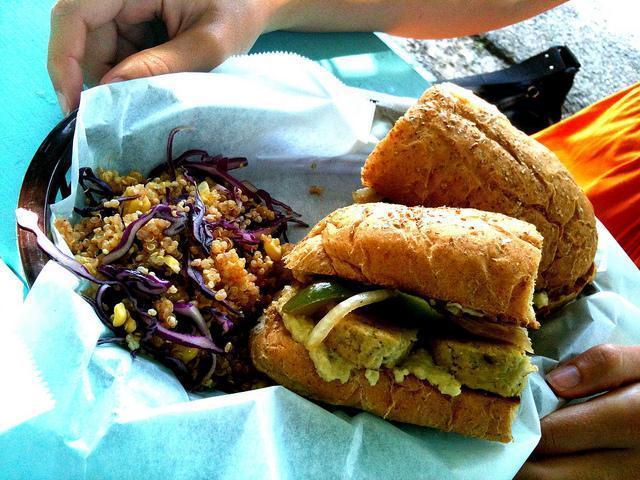Does the description: "The sandwich is at the edge of the bowl." accurately reflect the image?
Answer yes or no. Yes. Does the caption "The sandwich is at the right side of the bowl." correctly depict the image?
Answer yes or no. Yes. Does the description: "The bowl is under the sandwich." accurately reflect the image?
Answer yes or no. Yes. Is the caption "The sandwich is in the middle of the bowl." a true representation of the image?
Answer yes or no. No. 